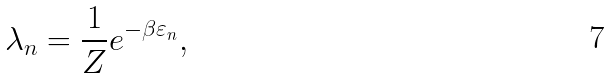Convert formula to latex. <formula><loc_0><loc_0><loc_500><loc_500>\lambda _ { n } = \frac { 1 } { Z } e ^ { - \beta \varepsilon _ { n } } ,</formula> 